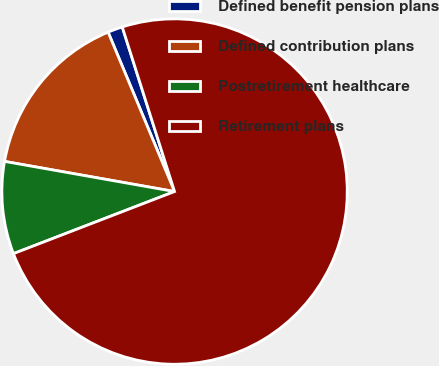Convert chart to OTSL. <chart><loc_0><loc_0><loc_500><loc_500><pie_chart><fcel>Defined benefit pension plans<fcel>Defined contribution plans<fcel>Postretirement healthcare<fcel>Retirement plans<nl><fcel>1.39%<fcel>15.92%<fcel>8.65%<fcel>74.04%<nl></chart> 